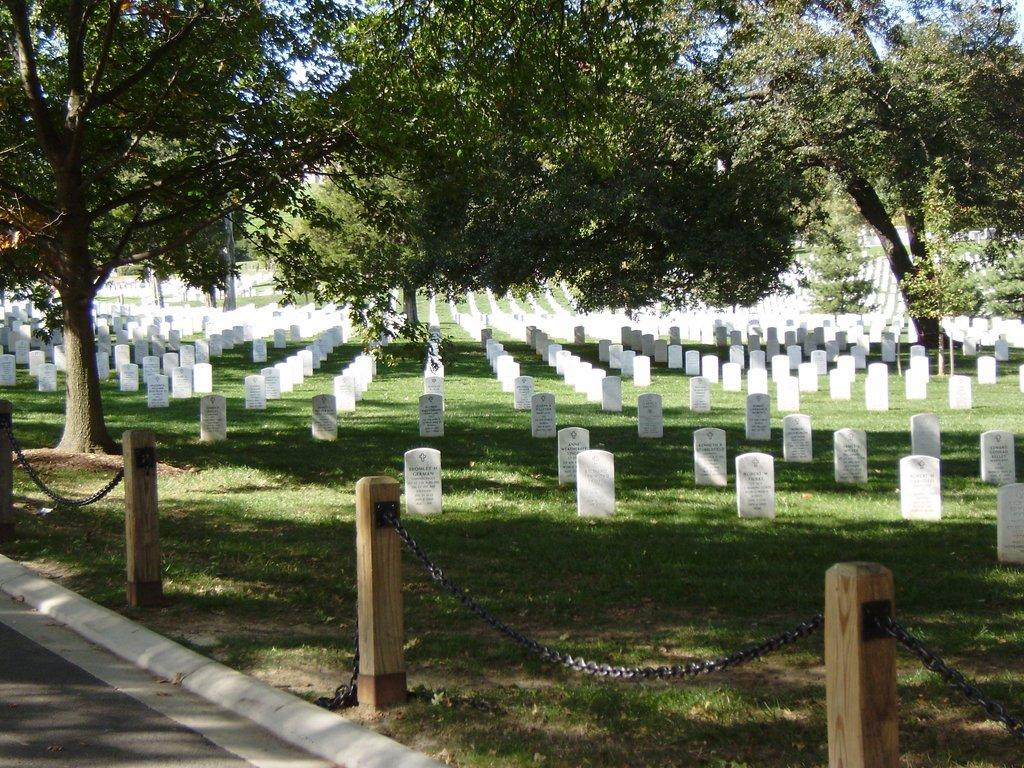What type of location is depicted in the image? The image contains cemeteries. What type of vegetation can be seen in the image? Grass is present in the image. What type of structures are visible in the image? Wooden poles and a walkway are visible in the image. What type of material is used for the chains in the image? The chains in the image are made of metal. What can be seen in the background of the image? There is a group of trees in the background of the image. What type of notebook is being used by the person in the image? There is no person present in the image, and therefore no notebook can be observed. 